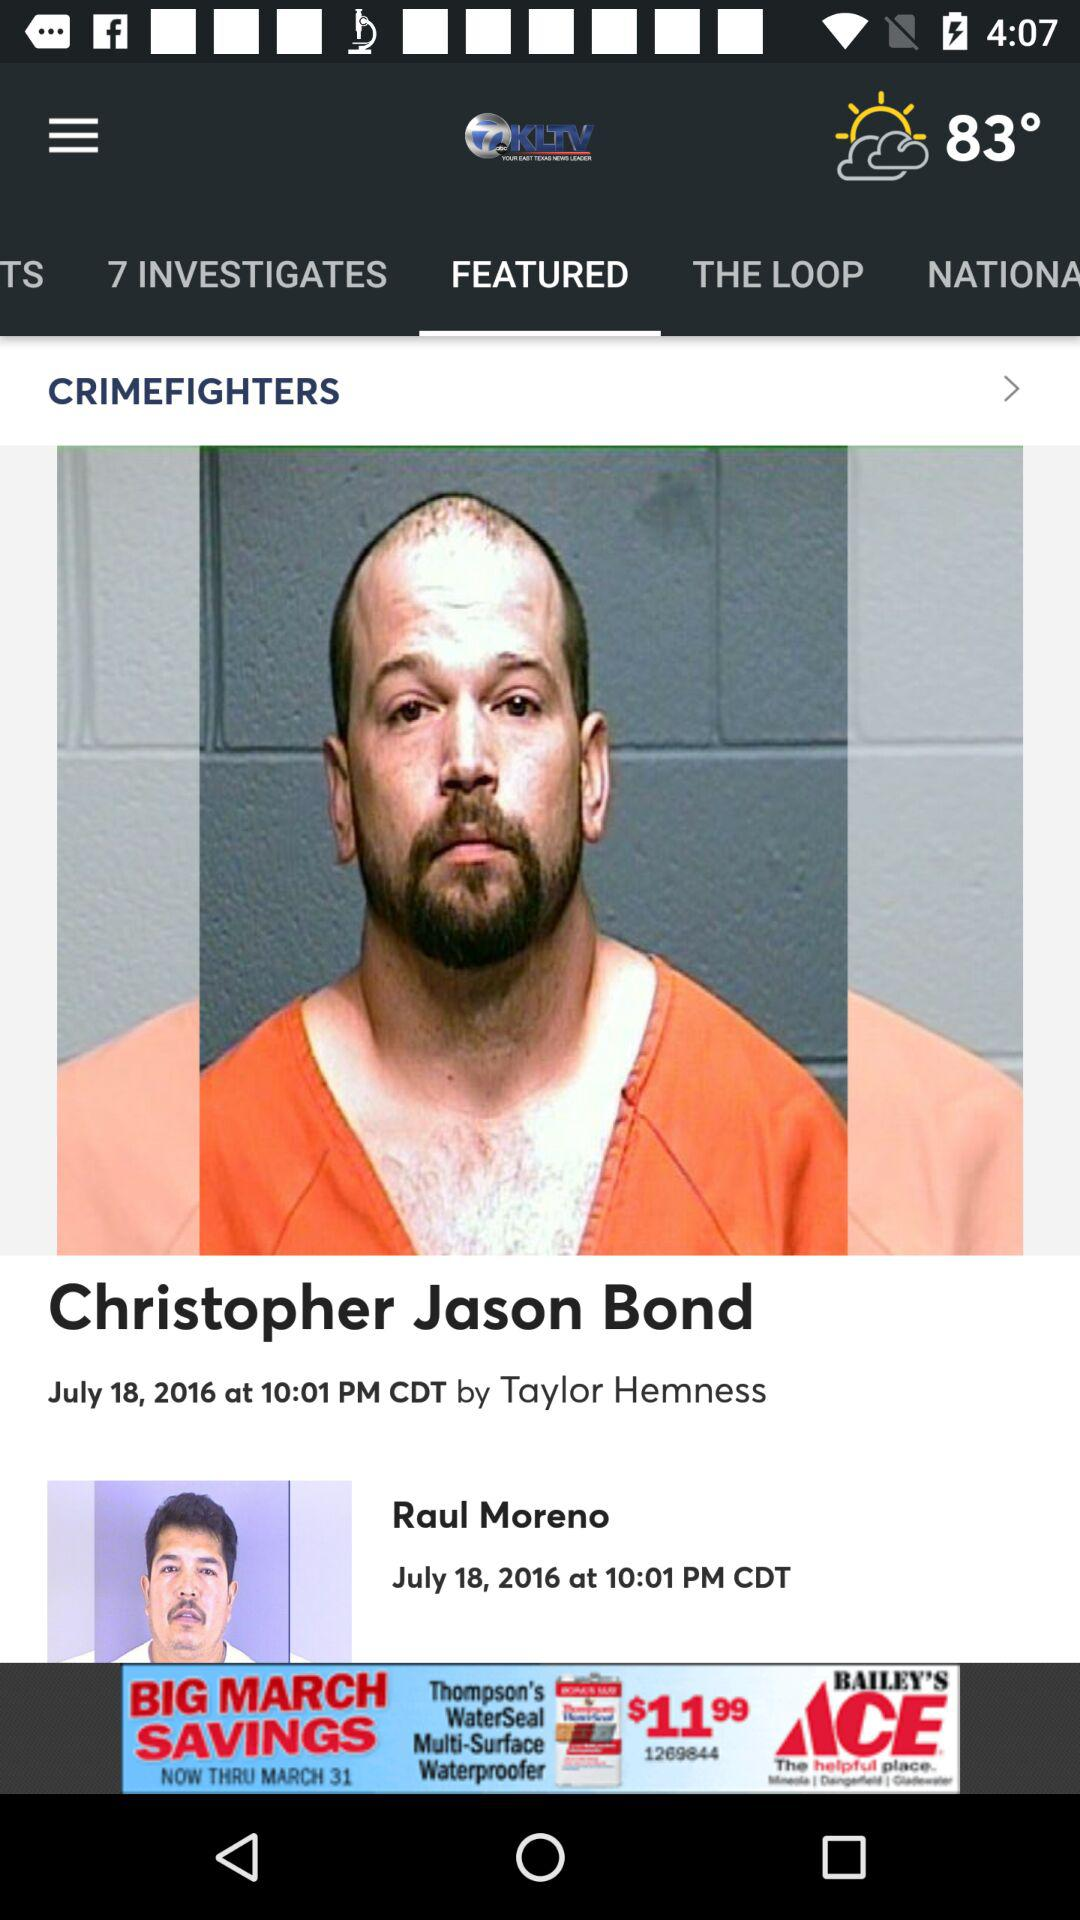What is the temperature? The temperature is 83°. 